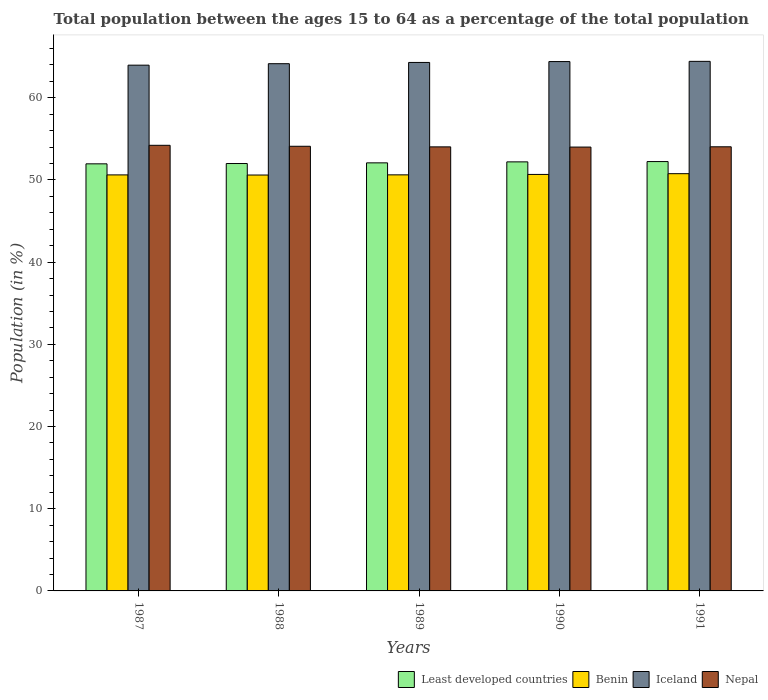How many bars are there on the 4th tick from the left?
Your answer should be very brief. 4. How many bars are there on the 1st tick from the right?
Provide a succinct answer. 4. In how many cases, is the number of bars for a given year not equal to the number of legend labels?
Your answer should be very brief. 0. What is the percentage of the population ages 15 to 64 in Nepal in 1991?
Provide a short and direct response. 54.04. Across all years, what is the maximum percentage of the population ages 15 to 64 in Iceland?
Your answer should be compact. 64.43. Across all years, what is the minimum percentage of the population ages 15 to 64 in Nepal?
Your response must be concise. 54. In which year was the percentage of the population ages 15 to 64 in Benin minimum?
Provide a succinct answer. 1988. What is the total percentage of the population ages 15 to 64 in Nepal in the graph?
Your response must be concise. 270.38. What is the difference between the percentage of the population ages 15 to 64 in Benin in 1990 and that in 1991?
Offer a terse response. -0.09. What is the difference between the percentage of the population ages 15 to 64 in Least developed countries in 1987 and the percentage of the population ages 15 to 64 in Iceland in 1990?
Keep it short and to the point. -12.44. What is the average percentage of the population ages 15 to 64 in Nepal per year?
Your answer should be very brief. 54.08. In the year 1988, what is the difference between the percentage of the population ages 15 to 64 in Least developed countries and percentage of the population ages 15 to 64 in Nepal?
Keep it short and to the point. -2.1. In how many years, is the percentage of the population ages 15 to 64 in Iceland greater than 36?
Make the answer very short. 5. What is the ratio of the percentage of the population ages 15 to 64 in Iceland in 1988 to that in 1989?
Keep it short and to the point. 1. Is the percentage of the population ages 15 to 64 in Iceland in 1987 less than that in 1990?
Provide a short and direct response. Yes. What is the difference between the highest and the second highest percentage of the population ages 15 to 64 in Least developed countries?
Provide a succinct answer. 0.04. What is the difference between the highest and the lowest percentage of the population ages 15 to 64 in Least developed countries?
Provide a short and direct response. 0.28. In how many years, is the percentage of the population ages 15 to 64 in Iceland greater than the average percentage of the population ages 15 to 64 in Iceland taken over all years?
Provide a short and direct response. 3. Is the sum of the percentage of the population ages 15 to 64 in Iceland in 1987 and 1988 greater than the maximum percentage of the population ages 15 to 64 in Least developed countries across all years?
Provide a short and direct response. Yes. Is it the case that in every year, the sum of the percentage of the population ages 15 to 64 in Iceland and percentage of the population ages 15 to 64 in Least developed countries is greater than the sum of percentage of the population ages 15 to 64 in Nepal and percentage of the population ages 15 to 64 in Benin?
Offer a terse response. Yes. What does the 4th bar from the left in 1991 represents?
Ensure brevity in your answer.  Nepal. What does the 4th bar from the right in 1991 represents?
Make the answer very short. Least developed countries. Is it the case that in every year, the sum of the percentage of the population ages 15 to 64 in Nepal and percentage of the population ages 15 to 64 in Benin is greater than the percentage of the population ages 15 to 64 in Least developed countries?
Your answer should be compact. Yes. How many years are there in the graph?
Ensure brevity in your answer.  5. Does the graph contain any zero values?
Keep it short and to the point. No. Where does the legend appear in the graph?
Your response must be concise. Bottom right. What is the title of the graph?
Ensure brevity in your answer.  Total population between the ages 15 to 64 as a percentage of the total population. Does "Algeria" appear as one of the legend labels in the graph?
Your response must be concise. No. What is the label or title of the X-axis?
Your response must be concise. Years. What is the Population (in %) in Least developed countries in 1987?
Give a very brief answer. 51.96. What is the Population (in %) in Benin in 1987?
Keep it short and to the point. 50.62. What is the Population (in %) of Iceland in 1987?
Give a very brief answer. 63.97. What is the Population (in %) of Nepal in 1987?
Offer a terse response. 54.22. What is the Population (in %) of Least developed countries in 1988?
Your response must be concise. 52. What is the Population (in %) of Benin in 1988?
Your answer should be compact. 50.6. What is the Population (in %) of Iceland in 1988?
Give a very brief answer. 64.15. What is the Population (in %) of Nepal in 1988?
Offer a terse response. 54.1. What is the Population (in %) of Least developed countries in 1989?
Make the answer very short. 52.08. What is the Population (in %) of Benin in 1989?
Your answer should be very brief. 50.62. What is the Population (in %) of Iceland in 1989?
Your response must be concise. 64.3. What is the Population (in %) in Nepal in 1989?
Your response must be concise. 54.03. What is the Population (in %) in Least developed countries in 1990?
Keep it short and to the point. 52.2. What is the Population (in %) of Benin in 1990?
Your answer should be compact. 50.67. What is the Population (in %) in Iceland in 1990?
Ensure brevity in your answer.  64.41. What is the Population (in %) in Nepal in 1990?
Make the answer very short. 54. What is the Population (in %) of Least developed countries in 1991?
Keep it short and to the point. 52.24. What is the Population (in %) in Benin in 1991?
Provide a succinct answer. 50.77. What is the Population (in %) in Iceland in 1991?
Offer a very short reply. 64.43. What is the Population (in %) of Nepal in 1991?
Ensure brevity in your answer.  54.04. Across all years, what is the maximum Population (in %) in Least developed countries?
Make the answer very short. 52.24. Across all years, what is the maximum Population (in %) of Benin?
Provide a succinct answer. 50.77. Across all years, what is the maximum Population (in %) of Iceland?
Provide a succinct answer. 64.43. Across all years, what is the maximum Population (in %) in Nepal?
Provide a succinct answer. 54.22. Across all years, what is the minimum Population (in %) of Least developed countries?
Offer a terse response. 51.96. Across all years, what is the minimum Population (in %) of Benin?
Provide a short and direct response. 50.6. Across all years, what is the minimum Population (in %) in Iceland?
Offer a very short reply. 63.97. Across all years, what is the minimum Population (in %) in Nepal?
Give a very brief answer. 54. What is the total Population (in %) in Least developed countries in the graph?
Offer a very short reply. 260.48. What is the total Population (in %) of Benin in the graph?
Offer a very short reply. 253.28. What is the total Population (in %) in Iceland in the graph?
Provide a short and direct response. 321.25. What is the total Population (in %) of Nepal in the graph?
Your answer should be very brief. 270.38. What is the difference between the Population (in %) of Least developed countries in 1987 and that in 1988?
Keep it short and to the point. -0.04. What is the difference between the Population (in %) of Benin in 1987 and that in 1988?
Your response must be concise. 0.02. What is the difference between the Population (in %) of Iceland in 1987 and that in 1988?
Your answer should be very brief. -0.18. What is the difference between the Population (in %) of Nepal in 1987 and that in 1988?
Provide a short and direct response. 0.12. What is the difference between the Population (in %) in Least developed countries in 1987 and that in 1989?
Your response must be concise. -0.12. What is the difference between the Population (in %) of Benin in 1987 and that in 1989?
Offer a very short reply. -0.01. What is the difference between the Population (in %) of Iceland in 1987 and that in 1989?
Provide a succinct answer. -0.33. What is the difference between the Population (in %) in Nepal in 1987 and that in 1989?
Give a very brief answer. 0.19. What is the difference between the Population (in %) in Least developed countries in 1987 and that in 1990?
Your answer should be compact. -0.24. What is the difference between the Population (in %) of Benin in 1987 and that in 1990?
Provide a short and direct response. -0.06. What is the difference between the Population (in %) in Iceland in 1987 and that in 1990?
Ensure brevity in your answer.  -0.44. What is the difference between the Population (in %) in Nepal in 1987 and that in 1990?
Ensure brevity in your answer.  0.21. What is the difference between the Population (in %) of Least developed countries in 1987 and that in 1991?
Your answer should be compact. -0.28. What is the difference between the Population (in %) of Benin in 1987 and that in 1991?
Provide a short and direct response. -0.15. What is the difference between the Population (in %) of Iceland in 1987 and that in 1991?
Offer a very short reply. -0.46. What is the difference between the Population (in %) in Nepal in 1987 and that in 1991?
Provide a succinct answer. 0.18. What is the difference between the Population (in %) of Least developed countries in 1988 and that in 1989?
Your answer should be compact. -0.08. What is the difference between the Population (in %) of Benin in 1988 and that in 1989?
Provide a short and direct response. -0.02. What is the difference between the Population (in %) of Iceland in 1988 and that in 1989?
Offer a terse response. -0.15. What is the difference between the Population (in %) in Nepal in 1988 and that in 1989?
Give a very brief answer. 0.07. What is the difference between the Population (in %) of Least developed countries in 1988 and that in 1990?
Offer a very short reply. -0.2. What is the difference between the Population (in %) of Benin in 1988 and that in 1990?
Give a very brief answer. -0.07. What is the difference between the Population (in %) in Iceland in 1988 and that in 1990?
Offer a terse response. -0.26. What is the difference between the Population (in %) in Nepal in 1988 and that in 1990?
Provide a short and direct response. 0.1. What is the difference between the Population (in %) of Least developed countries in 1988 and that in 1991?
Provide a short and direct response. -0.24. What is the difference between the Population (in %) of Benin in 1988 and that in 1991?
Offer a very short reply. -0.16. What is the difference between the Population (in %) in Iceland in 1988 and that in 1991?
Provide a succinct answer. -0.29. What is the difference between the Population (in %) of Nepal in 1988 and that in 1991?
Ensure brevity in your answer.  0.06. What is the difference between the Population (in %) of Least developed countries in 1989 and that in 1990?
Your response must be concise. -0.12. What is the difference between the Population (in %) in Benin in 1989 and that in 1990?
Your answer should be compact. -0.05. What is the difference between the Population (in %) of Iceland in 1989 and that in 1990?
Make the answer very short. -0.11. What is the difference between the Population (in %) of Nepal in 1989 and that in 1990?
Your answer should be very brief. 0.03. What is the difference between the Population (in %) in Least developed countries in 1989 and that in 1991?
Offer a very short reply. -0.16. What is the difference between the Population (in %) in Benin in 1989 and that in 1991?
Offer a terse response. -0.14. What is the difference between the Population (in %) in Iceland in 1989 and that in 1991?
Your response must be concise. -0.13. What is the difference between the Population (in %) of Nepal in 1989 and that in 1991?
Provide a succinct answer. -0.01. What is the difference between the Population (in %) in Least developed countries in 1990 and that in 1991?
Your answer should be very brief. -0.04. What is the difference between the Population (in %) in Benin in 1990 and that in 1991?
Give a very brief answer. -0.09. What is the difference between the Population (in %) in Iceland in 1990 and that in 1991?
Offer a very short reply. -0.03. What is the difference between the Population (in %) in Nepal in 1990 and that in 1991?
Make the answer very short. -0.03. What is the difference between the Population (in %) in Least developed countries in 1987 and the Population (in %) in Benin in 1988?
Make the answer very short. 1.36. What is the difference between the Population (in %) of Least developed countries in 1987 and the Population (in %) of Iceland in 1988?
Your response must be concise. -12.18. What is the difference between the Population (in %) in Least developed countries in 1987 and the Population (in %) in Nepal in 1988?
Your answer should be very brief. -2.14. What is the difference between the Population (in %) of Benin in 1987 and the Population (in %) of Iceland in 1988?
Your answer should be compact. -13.53. What is the difference between the Population (in %) in Benin in 1987 and the Population (in %) in Nepal in 1988?
Keep it short and to the point. -3.48. What is the difference between the Population (in %) in Iceland in 1987 and the Population (in %) in Nepal in 1988?
Offer a very short reply. 9.87. What is the difference between the Population (in %) in Least developed countries in 1987 and the Population (in %) in Benin in 1989?
Offer a terse response. 1.34. What is the difference between the Population (in %) in Least developed countries in 1987 and the Population (in %) in Iceland in 1989?
Offer a terse response. -12.34. What is the difference between the Population (in %) in Least developed countries in 1987 and the Population (in %) in Nepal in 1989?
Ensure brevity in your answer.  -2.07. What is the difference between the Population (in %) of Benin in 1987 and the Population (in %) of Iceland in 1989?
Keep it short and to the point. -13.68. What is the difference between the Population (in %) in Benin in 1987 and the Population (in %) in Nepal in 1989?
Provide a succinct answer. -3.41. What is the difference between the Population (in %) of Iceland in 1987 and the Population (in %) of Nepal in 1989?
Keep it short and to the point. 9.94. What is the difference between the Population (in %) of Least developed countries in 1987 and the Population (in %) of Benin in 1990?
Your answer should be compact. 1.29. What is the difference between the Population (in %) in Least developed countries in 1987 and the Population (in %) in Iceland in 1990?
Keep it short and to the point. -12.44. What is the difference between the Population (in %) in Least developed countries in 1987 and the Population (in %) in Nepal in 1990?
Ensure brevity in your answer.  -2.04. What is the difference between the Population (in %) in Benin in 1987 and the Population (in %) in Iceland in 1990?
Ensure brevity in your answer.  -13.79. What is the difference between the Population (in %) of Benin in 1987 and the Population (in %) of Nepal in 1990?
Keep it short and to the point. -3.39. What is the difference between the Population (in %) in Iceland in 1987 and the Population (in %) in Nepal in 1990?
Provide a succinct answer. 9.97. What is the difference between the Population (in %) in Least developed countries in 1987 and the Population (in %) in Benin in 1991?
Offer a very short reply. 1.2. What is the difference between the Population (in %) of Least developed countries in 1987 and the Population (in %) of Iceland in 1991?
Give a very brief answer. -12.47. What is the difference between the Population (in %) of Least developed countries in 1987 and the Population (in %) of Nepal in 1991?
Provide a succinct answer. -2.07. What is the difference between the Population (in %) of Benin in 1987 and the Population (in %) of Iceland in 1991?
Your answer should be compact. -13.82. What is the difference between the Population (in %) in Benin in 1987 and the Population (in %) in Nepal in 1991?
Provide a short and direct response. -3.42. What is the difference between the Population (in %) in Iceland in 1987 and the Population (in %) in Nepal in 1991?
Your answer should be very brief. 9.93. What is the difference between the Population (in %) in Least developed countries in 1988 and the Population (in %) in Benin in 1989?
Your response must be concise. 1.38. What is the difference between the Population (in %) in Least developed countries in 1988 and the Population (in %) in Iceland in 1989?
Your response must be concise. -12.3. What is the difference between the Population (in %) in Least developed countries in 1988 and the Population (in %) in Nepal in 1989?
Make the answer very short. -2.03. What is the difference between the Population (in %) in Benin in 1988 and the Population (in %) in Iceland in 1989?
Give a very brief answer. -13.7. What is the difference between the Population (in %) in Benin in 1988 and the Population (in %) in Nepal in 1989?
Keep it short and to the point. -3.43. What is the difference between the Population (in %) in Iceland in 1988 and the Population (in %) in Nepal in 1989?
Provide a succinct answer. 10.12. What is the difference between the Population (in %) in Least developed countries in 1988 and the Population (in %) in Benin in 1990?
Provide a succinct answer. 1.33. What is the difference between the Population (in %) of Least developed countries in 1988 and the Population (in %) of Iceland in 1990?
Make the answer very short. -12.41. What is the difference between the Population (in %) in Least developed countries in 1988 and the Population (in %) in Nepal in 1990?
Your answer should be compact. -2. What is the difference between the Population (in %) of Benin in 1988 and the Population (in %) of Iceland in 1990?
Offer a very short reply. -13.8. What is the difference between the Population (in %) of Benin in 1988 and the Population (in %) of Nepal in 1990?
Your response must be concise. -3.4. What is the difference between the Population (in %) of Iceland in 1988 and the Population (in %) of Nepal in 1990?
Offer a very short reply. 10.14. What is the difference between the Population (in %) of Least developed countries in 1988 and the Population (in %) of Benin in 1991?
Offer a terse response. 1.23. What is the difference between the Population (in %) of Least developed countries in 1988 and the Population (in %) of Iceland in 1991?
Ensure brevity in your answer.  -12.43. What is the difference between the Population (in %) in Least developed countries in 1988 and the Population (in %) in Nepal in 1991?
Give a very brief answer. -2.04. What is the difference between the Population (in %) of Benin in 1988 and the Population (in %) of Iceland in 1991?
Provide a short and direct response. -13.83. What is the difference between the Population (in %) of Benin in 1988 and the Population (in %) of Nepal in 1991?
Ensure brevity in your answer.  -3.44. What is the difference between the Population (in %) in Iceland in 1988 and the Population (in %) in Nepal in 1991?
Your answer should be compact. 10.11. What is the difference between the Population (in %) of Least developed countries in 1989 and the Population (in %) of Benin in 1990?
Give a very brief answer. 1.41. What is the difference between the Population (in %) of Least developed countries in 1989 and the Population (in %) of Iceland in 1990?
Keep it short and to the point. -12.32. What is the difference between the Population (in %) in Least developed countries in 1989 and the Population (in %) in Nepal in 1990?
Offer a terse response. -1.92. What is the difference between the Population (in %) of Benin in 1989 and the Population (in %) of Iceland in 1990?
Your response must be concise. -13.78. What is the difference between the Population (in %) in Benin in 1989 and the Population (in %) in Nepal in 1990?
Keep it short and to the point. -3.38. What is the difference between the Population (in %) in Iceland in 1989 and the Population (in %) in Nepal in 1990?
Ensure brevity in your answer.  10.3. What is the difference between the Population (in %) of Least developed countries in 1989 and the Population (in %) of Benin in 1991?
Make the answer very short. 1.32. What is the difference between the Population (in %) of Least developed countries in 1989 and the Population (in %) of Iceland in 1991?
Keep it short and to the point. -12.35. What is the difference between the Population (in %) of Least developed countries in 1989 and the Population (in %) of Nepal in 1991?
Give a very brief answer. -1.95. What is the difference between the Population (in %) of Benin in 1989 and the Population (in %) of Iceland in 1991?
Make the answer very short. -13.81. What is the difference between the Population (in %) in Benin in 1989 and the Population (in %) in Nepal in 1991?
Offer a very short reply. -3.41. What is the difference between the Population (in %) of Iceland in 1989 and the Population (in %) of Nepal in 1991?
Make the answer very short. 10.26. What is the difference between the Population (in %) of Least developed countries in 1990 and the Population (in %) of Benin in 1991?
Your answer should be compact. 1.44. What is the difference between the Population (in %) in Least developed countries in 1990 and the Population (in %) in Iceland in 1991?
Provide a short and direct response. -12.23. What is the difference between the Population (in %) of Least developed countries in 1990 and the Population (in %) of Nepal in 1991?
Give a very brief answer. -1.83. What is the difference between the Population (in %) in Benin in 1990 and the Population (in %) in Iceland in 1991?
Your answer should be compact. -13.76. What is the difference between the Population (in %) of Benin in 1990 and the Population (in %) of Nepal in 1991?
Your answer should be very brief. -3.36. What is the difference between the Population (in %) of Iceland in 1990 and the Population (in %) of Nepal in 1991?
Offer a terse response. 10.37. What is the average Population (in %) of Least developed countries per year?
Provide a short and direct response. 52.1. What is the average Population (in %) in Benin per year?
Make the answer very short. 50.66. What is the average Population (in %) in Iceland per year?
Offer a terse response. 64.25. What is the average Population (in %) in Nepal per year?
Make the answer very short. 54.08. In the year 1987, what is the difference between the Population (in %) of Least developed countries and Population (in %) of Benin?
Give a very brief answer. 1.35. In the year 1987, what is the difference between the Population (in %) in Least developed countries and Population (in %) in Iceland?
Offer a terse response. -12.01. In the year 1987, what is the difference between the Population (in %) in Least developed countries and Population (in %) in Nepal?
Your answer should be compact. -2.25. In the year 1987, what is the difference between the Population (in %) of Benin and Population (in %) of Iceland?
Offer a terse response. -13.35. In the year 1987, what is the difference between the Population (in %) in Benin and Population (in %) in Nepal?
Ensure brevity in your answer.  -3.6. In the year 1987, what is the difference between the Population (in %) in Iceland and Population (in %) in Nepal?
Your response must be concise. 9.75. In the year 1988, what is the difference between the Population (in %) in Least developed countries and Population (in %) in Benin?
Make the answer very short. 1.4. In the year 1988, what is the difference between the Population (in %) in Least developed countries and Population (in %) in Iceland?
Your answer should be very brief. -12.15. In the year 1988, what is the difference between the Population (in %) of Least developed countries and Population (in %) of Nepal?
Keep it short and to the point. -2.1. In the year 1988, what is the difference between the Population (in %) in Benin and Population (in %) in Iceland?
Your response must be concise. -13.54. In the year 1988, what is the difference between the Population (in %) of Benin and Population (in %) of Nepal?
Your answer should be compact. -3.5. In the year 1988, what is the difference between the Population (in %) of Iceland and Population (in %) of Nepal?
Your response must be concise. 10.05. In the year 1989, what is the difference between the Population (in %) in Least developed countries and Population (in %) in Benin?
Your answer should be compact. 1.46. In the year 1989, what is the difference between the Population (in %) of Least developed countries and Population (in %) of Iceland?
Ensure brevity in your answer.  -12.22. In the year 1989, what is the difference between the Population (in %) of Least developed countries and Population (in %) of Nepal?
Give a very brief answer. -1.95. In the year 1989, what is the difference between the Population (in %) in Benin and Population (in %) in Iceland?
Offer a terse response. -13.68. In the year 1989, what is the difference between the Population (in %) of Benin and Population (in %) of Nepal?
Keep it short and to the point. -3.4. In the year 1989, what is the difference between the Population (in %) of Iceland and Population (in %) of Nepal?
Give a very brief answer. 10.27. In the year 1990, what is the difference between the Population (in %) of Least developed countries and Population (in %) of Benin?
Make the answer very short. 1.53. In the year 1990, what is the difference between the Population (in %) in Least developed countries and Population (in %) in Iceland?
Make the answer very short. -12.2. In the year 1990, what is the difference between the Population (in %) of Least developed countries and Population (in %) of Nepal?
Your answer should be very brief. -1.8. In the year 1990, what is the difference between the Population (in %) in Benin and Population (in %) in Iceland?
Keep it short and to the point. -13.73. In the year 1990, what is the difference between the Population (in %) of Benin and Population (in %) of Nepal?
Provide a succinct answer. -3.33. In the year 1990, what is the difference between the Population (in %) in Iceland and Population (in %) in Nepal?
Your response must be concise. 10.4. In the year 1991, what is the difference between the Population (in %) of Least developed countries and Population (in %) of Benin?
Give a very brief answer. 1.47. In the year 1991, what is the difference between the Population (in %) in Least developed countries and Population (in %) in Iceland?
Provide a succinct answer. -12.19. In the year 1991, what is the difference between the Population (in %) in Least developed countries and Population (in %) in Nepal?
Provide a succinct answer. -1.8. In the year 1991, what is the difference between the Population (in %) in Benin and Population (in %) in Iceland?
Offer a terse response. -13.67. In the year 1991, what is the difference between the Population (in %) of Benin and Population (in %) of Nepal?
Make the answer very short. -3.27. In the year 1991, what is the difference between the Population (in %) in Iceland and Population (in %) in Nepal?
Your answer should be very brief. 10.4. What is the ratio of the Population (in %) of Benin in 1987 to that in 1988?
Make the answer very short. 1. What is the ratio of the Population (in %) in Iceland in 1987 to that in 1988?
Make the answer very short. 1. What is the ratio of the Population (in %) of Nepal in 1987 to that in 1988?
Make the answer very short. 1. What is the ratio of the Population (in %) of Least developed countries in 1987 to that in 1989?
Provide a succinct answer. 1. What is the ratio of the Population (in %) of Benin in 1987 to that in 1989?
Provide a short and direct response. 1. What is the ratio of the Population (in %) of Least developed countries in 1987 to that in 1990?
Offer a terse response. 1. What is the ratio of the Population (in %) in Nepal in 1987 to that in 1990?
Provide a short and direct response. 1. What is the ratio of the Population (in %) of Least developed countries in 1987 to that in 1991?
Offer a very short reply. 0.99. What is the ratio of the Population (in %) of Iceland in 1987 to that in 1991?
Give a very brief answer. 0.99. What is the ratio of the Population (in %) in Nepal in 1987 to that in 1991?
Your answer should be very brief. 1. What is the ratio of the Population (in %) of Iceland in 1988 to that in 1989?
Ensure brevity in your answer.  1. What is the ratio of the Population (in %) of Nepal in 1988 to that in 1989?
Offer a very short reply. 1. What is the ratio of the Population (in %) of Iceland in 1988 to that in 1990?
Give a very brief answer. 1. What is the ratio of the Population (in %) in Nepal in 1988 to that in 1990?
Offer a very short reply. 1. What is the ratio of the Population (in %) in Least developed countries in 1988 to that in 1991?
Your answer should be very brief. 1. What is the ratio of the Population (in %) of Iceland in 1988 to that in 1991?
Offer a very short reply. 1. What is the ratio of the Population (in %) in Nepal in 1988 to that in 1991?
Provide a succinct answer. 1. What is the ratio of the Population (in %) of Least developed countries in 1989 to that in 1990?
Your answer should be very brief. 1. What is the ratio of the Population (in %) of Nepal in 1989 to that in 1990?
Offer a very short reply. 1. What is the ratio of the Population (in %) in Least developed countries in 1989 to that in 1991?
Offer a terse response. 1. What is the ratio of the Population (in %) of Benin in 1989 to that in 1991?
Your response must be concise. 1. What is the ratio of the Population (in %) in Least developed countries in 1990 to that in 1991?
Ensure brevity in your answer.  1. What is the ratio of the Population (in %) in Benin in 1990 to that in 1991?
Offer a very short reply. 1. What is the ratio of the Population (in %) of Nepal in 1990 to that in 1991?
Provide a succinct answer. 1. What is the difference between the highest and the second highest Population (in %) in Least developed countries?
Provide a short and direct response. 0.04. What is the difference between the highest and the second highest Population (in %) in Benin?
Your answer should be compact. 0.09. What is the difference between the highest and the second highest Population (in %) in Iceland?
Make the answer very short. 0.03. What is the difference between the highest and the second highest Population (in %) of Nepal?
Your response must be concise. 0.12. What is the difference between the highest and the lowest Population (in %) of Least developed countries?
Ensure brevity in your answer.  0.28. What is the difference between the highest and the lowest Population (in %) in Benin?
Keep it short and to the point. 0.16. What is the difference between the highest and the lowest Population (in %) of Iceland?
Your answer should be compact. 0.46. What is the difference between the highest and the lowest Population (in %) of Nepal?
Make the answer very short. 0.21. 